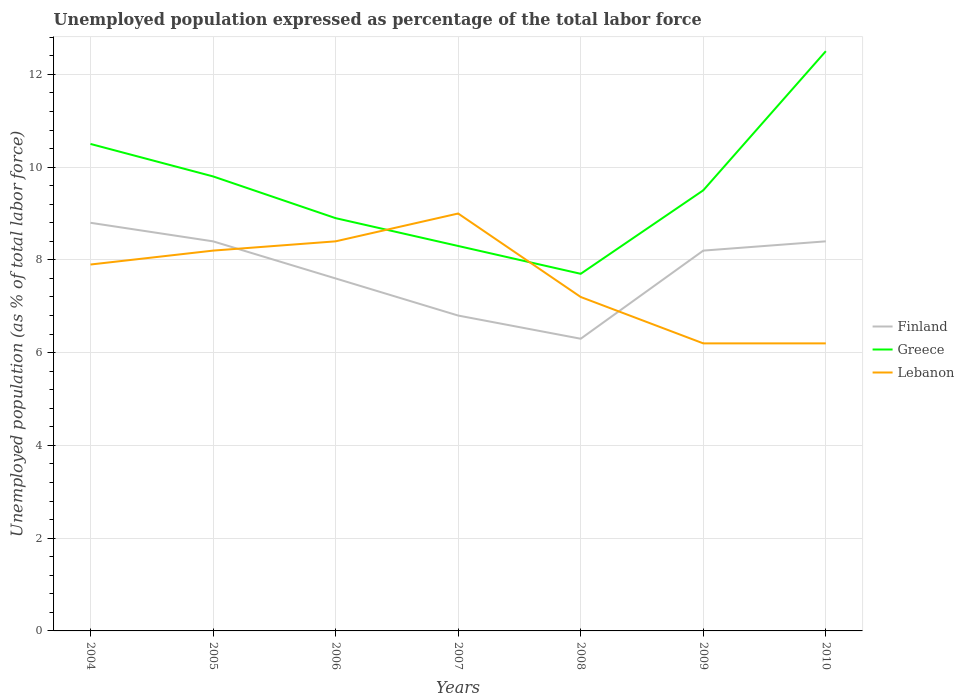How many different coloured lines are there?
Ensure brevity in your answer.  3. Does the line corresponding to Lebanon intersect with the line corresponding to Finland?
Offer a very short reply. Yes. Is the number of lines equal to the number of legend labels?
Make the answer very short. Yes. Across all years, what is the maximum unemployment in in Greece?
Offer a terse response. 7.7. What is the total unemployment in in Finland in the graph?
Your answer should be compact. 0.5. What is the difference between the highest and the second highest unemployment in in Greece?
Give a very brief answer. 4.8. How many years are there in the graph?
Your answer should be compact. 7. What is the difference between two consecutive major ticks on the Y-axis?
Offer a terse response. 2. Does the graph contain grids?
Keep it short and to the point. Yes. How many legend labels are there?
Provide a short and direct response. 3. How are the legend labels stacked?
Keep it short and to the point. Vertical. What is the title of the graph?
Give a very brief answer. Unemployed population expressed as percentage of the total labor force. Does "Moldova" appear as one of the legend labels in the graph?
Make the answer very short. No. What is the label or title of the Y-axis?
Offer a terse response. Unemployed population (as % of total labor force). What is the Unemployed population (as % of total labor force) in Finland in 2004?
Give a very brief answer. 8.8. What is the Unemployed population (as % of total labor force) of Lebanon in 2004?
Make the answer very short. 7.9. What is the Unemployed population (as % of total labor force) of Finland in 2005?
Your response must be concise. 8.4. What is the Unemployed population (as % of total labor force) of Greece in 2005?
Provide a short and direct response. 9.8. What is the Unemployed population (as % of total labor force) of Lebanon in 2005?
Keep it short and to the point. 8.2. What is the Unemployed population (as % of total labor force) in Finland in 2006?
Your answer should be very brief. 7.6. What is the Unemployed population (as % of total labor force) in Greece in 2006?
Offer a terse response. 8.9. What is the Unemployed population (as % of total labor force) in Lebanon in 2006?
Make the answer very short. 8.4. What is the Unemployed population (as % of total labor force) in Finland in 2007?
Your response must be concise. 6.8. What is the Unemployed population (as % of total labor force) in Greece in 2007?
Keep it short and to the point. 8.3. What is the Unemployed population (as % of total labor force) in Finland in 2008?
Make the answer very short. 6.3. What is the Unemployed population (as % of total labor force) of Greece in 2008?
Make the answer very short. 7.7. What is the Unemployed population (as % of total labor force) of Lebanon in 2008?
Provide a short and direct response. 7.2. What is the Unemployed population (as % of total labor force) of Finland in 2009?
Your answer should be compact. 8.2. What is the Unemployed population (as % of total labor force) in Lebanon in 2009?
Your answer should be compact. 6.2. What is the Unemployed population (as % of total labor force) of Finland in 2010?
Provide a short and direct response. 8.4. What is the Unemployed population (as % of total labor force) of Lebanon in 2010?
Your answer should be very brief. 6.2. Across all years, what is the maximum Unemployed population (as % of total labor force) in Finland?
Ensure brevity in your answer.  8.8. Across all years, what is the maximum Unemployed population (as % of total labor force) in Greece?
Provide a short and direct response. 12.5. Across all years, what is the maximum Unemployed population (as % of total labor force) of Lebanon?
Your response must be concise. 9. Across all years, what is the minimum Unemployed population (as % of total labor force) of Finland?
Keep it short and to the point. 6.3. Across all years, what is the minimum Unemployed population (as % of total labor force) in Greece?
Provide a succinct answer. 7.7. Across all years, what is the minimum Unemployed population (as % of total labor force) in Lebanon?
Provide a short and direct response. 6.2. What is the total Unemployed population (as % of total labor force) of Finland in the graph?
Your answer should be compact. 54.5. What is the total Unemployed population (as % of total labor force) in Greece in the graph?
Your answer should be compact. 67.2. What is the total Unemployed population (as % of total labor force) in Lebanon in the graph?
Your answer should be compact. 53.1. What is the difference between the Unemployed population (as % of total labor force) in Finland in 2004 and that in 2005?
Offer a very short reply. 0.4. What is the difference between the Unemployed population (as % of total labor force) in Lebanon in 2004 and that in 2007?
Make the answer very short. -1.1. What is the difference between the Unemployed population (as % of total labor force) in Lebanon in 2004 and that in 2008?
Give a very brief answer. 0.7. What is the difference between the Unemployed population (as % of total labor force) in Greece in 2004 and that in 2009?
Provide a short and direct response. 1. What is the difference between the Unemployed population (as % of total labor force) in Lebanon in 2004 and that in 2009?
Provide a short and direct response. 1.7. What is the difference between the Unemployed population (as % of total labor force) of Greece in 2004 and that in 2010?
Provide a succinct answer. -2. What is the difference between the Unemployed population (as % of total labor force) in Lebanon in 2004 and that in 2010?
Provide a short and direct response. 1.7. What is the difference between the Unemployed population (as % of total labor force) of Greece in 2005 and that in 2006?
Provide a short and direct response. 0.9. What is the difference between the Unemployed population (as % of total labor force) of Lebanon in 2005 and that in 2007?
Give a very brief answer. -0.8. What is the difference between the Unemployed population (as % of total labor force) in Lebanon in 2005 and that in 2008?
Make the answer very short. 1. What is the difference between the Unemployed population (as % of total labor force) in Finland in 2005 and that in 2010?
Offer a terse response. 0. What is the difference between the Unemployed population (as % of total labor force) in Greece in 2005 and that in 2010?
Your answer should be compact. -2.7. What is the difference between the Unemployed population (as % of total labor force) of Lebanon in 2006 and that in 2008?
Your answer should be compact. 1.2. What is the difference between the Unemployed population (as % of total labor force) of Finland in 2006 and that in 2009?
Offer a terse response. -0.6. What is the difference between the Unemployed population (as % of total labor force) of Finland in 2007 and that in 2008?
Your answer should be compact. 0.5. What is the difference between the Unemployed population (as % of total labor force) of Finland in 2007 and that in 2009?
Provide a succinct answer. -1.4. What is the difference between the Unemployed population (as % of total labor force) in Greece in 2007 and that in 2009?
Your answer should be very brief. -1.2. What is the difference between the Unemployed population (as % of total labor force) in Lebanon in 2007 and that in 2009?
Your response must be concise. 2.8. What is the difference between the Unemployed population (as % of total labor force) of Finland in 2008 and that in 2009?
Provide a succinct answer. -1.9. What is the difference between the Unemployed population (as % of total labor force) in Greece in 2008 and that in 2010?
Your response must be concise. -4.8. What is the difference between the Unemployed population (as % of total labor force) of Lebanon in 2008 and that in 2010?
Offer a terse response. 1. What is the difference between the Unemployed population (as % of total labor force) in Finland in 2009 and that in 2010?
Provide a short and direct response. -0.2. What is the difference between the Unemployed population (as % of total labor force) in Finland in 2004 and the Unemployed population (as % of total labor force) in Greece in 2005?
Your answer should be very brief. -1. What is the difference between the Unemployed population (as % of total labor force) of Greece in 2004 and the Unemployed population (as % of total labor force) of Lebanon in 2005?
Your answer should be compact. 2.3. What is the difference between the Unemployed population (as % of total labor force) of Finland in 2004 and the Unemployed population (as % of total labor force) of Lebanon in 2006?
Your response must be concise. 0.4. What is the difference between the Unemployed population (as % of total labor force) of Finland in 2004 and the Unemployed population (as % of total labor force) of Greece in 2007?
Your answer should be very brief. 0.5. What is the difference between the Unemployed population (as % of total labor force) of Finland in 2004 and the Unemployed population (as % of total labor force) of Lebanon in 2007?
Your answer should be very brief. -0.2. What is the difference between the Unemployed population (as % of total labor force) of Greece in 2004 and the Unemployed population (as % of total labor force) of Lebanon in 2007?
Make the answer very short. 1.5. What is the difference between the Unemployed population (as % of total labor force) in Finland in 2004 and the Unemployed population (as % of total labor force) in Greece in 2008?
Keep it short and to the point. 1.1. What is the difference between the Unemployed population (as % of total labor force) in Greece in 2004 and the Unemployed population (as % of total labor force) in Lebanon in 2008?
Ensure brevity in your answer.  3.3. What is the difference between the Unemployed population (as % of total labor force) in Finland in 2004 and the Unemployed population (as % of total labor force) in Greece in 2009?
Provide a short and direct response. -0.7. What is the difference between the Unemployed population (as % of total labor force) in Finland in 2004 and the Unemployed population (as % of total labor force) in Lebanon in 2009?
Make the answer very short. 2.6. What is the difference between the Unemployed population (as % of total labor force) of Greece in 2004 and the Unemployed population (as % of total labor force) of Lebanon in 2010?
Keep it short and to the point. 4.3. What is the difference between the Unemployed population (as % of total labor force) of Finland in 2005 and the Unemployed population (as % of total labor force) of Greece in 2006?
Your response must be concise. -0.5. What is the difference between the Unemployed population (as % of total labor force) of Greece in 2005 and the Unemployed population (as % of total labor force) of Lebanon in 2006?
Provide a short and direct response. 1.4. What is the difference between the Unemployed population (as % of total labor force) of Finland in 2005 and the Unemployed population (as % of total labor force) of Greece in 2007?
Your answer should be compact. 0.1. What is the difference between the Unemployed population (as % of total labor force) of Finland in 2005 and the Unemployed population (as % of total labor force) of Lebanon in 2007?
Your response must be concise. -0.6. What is the difference between the Unemployed population (as % of total labor force) of Finland in 2005 and the Unemployed population (as % of total labor force) of Lebanon in 2008?
Give a very brief answer. 1.2. What is the difference between the Unemployed population (as % of total labor force) in Finland in 2005 and the Unemployed population (as % of total labor force) in Lebanon in 2009?
Ensure brevity in your answer.  2.2. What is the difference between the Unemployed population (as % of total labor force) in Greece in 2005 and the Unemployed population (as % of total labor force) in Lebanon in 2009?
Your answer should be compact. 3.6. What is the difference between the Unemployed population (as % of total labor force) of Finland in 2005 and the Unemployed population (as % of total labor force) of Greece in 2010?
Provide a succinct answer. -4.1. What is the difference between the Unemployed population (as % of total labor force) in Greece in 2005 and the Unemployed population (as % of total labor force) in Lebanon in 2010?
Give a very brief answer. 3.6. What is the difference between the Unemployed population (as % of total labor force) of Finland in 2006 and the Unemployed population (as % of total labor force) of Lebanon in 2007?
Your answer should be very brief. -1.4. What is the difference between the Unemployed population (as % of total labor force) of Greece in 2006 and the Unemployed population (as % of total labor force) of Lebanon in 2007?
Provide a succinct answer. -0.1. What is the difference between the Unemployed population (as % of total labor force) of Finland in 2006 and the Unemployed population (as % of total labor force) of Lebanon in 2008?
Your answer should be very brief. 0.4. What is the difference between the Unemployed population (as % of total labor force) in Greece in 2006 and the Unemployed population (as % of total labor force) in Lebanon in 2008?
Make the answer very short. 1.7. What is the difference between the Unemployed population (as % of total labor force) of Finland in 2006 and the Unemployed population (as % of total labor force) of Greece in 2009?
Your response must be concise. -1.9. What is the difference between the Unemployed population (as % of total labor force) in Finland in 2006 and the Unemployed population (as % of total labor force) in Greece in 2010?
Provide a succinct answer. -4.9. What is the difference between the Unemployed population (as % of total labor force) in Finland in 2007 and the Unemployed population (as % of total labor force) in Lebanon in 2008?
Your answer should be compact. -0.4. What is the difference between the Unemployed population (as % of total labor force) of Greece in 2007 and the Unemployed population (as % of total labor force) of Lebanon in 2008?
Make the answer very short. 1.1. What is the difference between the Unemployed population (as % of total labor force) of Finland in 2007 and the Unemployed population (as % of total labor force) of Greece in 2009?
Make the answer very short. -2.7. What is the difference between the Unemployed population (as % of total labor force) of Finland in 2007 and the Unemployed population (as % of total labor force) of Lebanon in 2010?
Your answer should be very brief. 0.6. What is the difference between the Unemployed population (as % of total labor force) in Finland in 2008 and the Unemployed population (as % of total labor force) in Greece in 2009?
Ensure brevity in your answer.  -3.2. What is the difference between the Unemployed population (as % of total labor force) in Greece in 2008 and the Unemployed population (as % of total labor force) in Lebanon in 2009?
Your answer should be very brief. 1.5. What is the difference between the Unemployed population (as % of total labor force) of Finland in 2008 and the Unemployed population (as % of total labor force) of Lebanon in 2010?
Your response must be concise. 0.1. What is the difference between the Unemployed population (as % of total labor force) of Finland in 2009 and the Unemployed population (as % of total labor force) of Lebanon in 2010?
Your response must be concise. 2. What is the average Unemployed population (as % of total labor force) in Finland per year?
Provide a succinct answer. 7.79. What is the average Unemployed population (as % of total labor force) of Lebanon per year?
Your answer should be compact. 7.59. In the year 2004, what is the difference between the Unemployed population (as % of total labor force) in Finland and Unemployed population (as % of total labor force) in Greece?
Provide a short and direct response. -1.7. In the year 2004, what is the difference between the Unemployed population (as % of total labor force) in Finland and Unemployed population (as % of total labor force) in Lebanon?
Give a very brief answer. 0.9. In the year 2005, what is the difference between the Unemployed population (as % of total labor force) in Finland and Unemployed population (as % of total labor force) in Greece?
Offer a terse response. -1.4. In the year 2005, what is the difference between the Unemployed population (as % of total labor force) in Finland and Unemployed population (as % of total labor force) in Lebanon?
Keep it short and to the point. 0.2. In the year 2005, what is the difference between the Unemployed population (as % of total labor force) in Greece and Unemployed population (as % of total labor force) in Lebanon?
Provide a short and direct response. 1.6. In the year 2007, what is the difference between the Unemployed population (as % of total labor force) in Finland and Unemployed population (as % of total labor force) in Greece?
Offer a terse response. -1.5. In the year 2007, what is the difference between the Unemployed population (as % of total labor force) in Greece and Unemployed population (as % of total labor force) in Lebanon?
Provide a succinct answer. -0.7. In the year 2008, what is the difference between the Unemployed population (as % of total labor force) of Finland and Unemployed population (as % of total labor force) of Greece?
Your response must be concise. -1.4. In the year 2008, what is the difference between the Unemployed population (as % of total labor force) of Greece and Unemployed population (as % of total labor force) of Lebanon?
Offer a very short reply. 0.5. In the year 2009, what is the difference between the Unemployed population (as % of total labor force) of Finland and Unemployed population (as % of total labor force) of Greece?
Your answer should be compact. -1.3. In the year 2010, what is the difference between the Unemployed population (as % of total labor force) of Finland and Unemployed population (as % of total labor force) of Lebanon?
Ensure brevity in your answer.  2.2. What is the ratio of the Unemployed population (as % of total labor force) in Finland in 2004 to that in 2005?
Make the answer very short. 1.05. What is the ratio of the Unemployed population (as % of total labor force) of Greece in 2004 to that in 2005?
Your answer should be compact. 1.07. What is the ratio of the Unemployed population (as % of total labor force) in Lebanon in 2004 to that in 2005?
Give a very brief answer. 0.96. What is the ratio of the Unemployed population (as % of total labor force) of Finland in 2004 to that in 2006?
Your answer should be compact. 1.16. What is the ratio of the Unemployed population (as % of total labor force) in Greece in 2004 to that in 2006?
Your answer should be very brief. 1.18. What is the ratio of the Unemployed population (as % of total labor force) in Lebanon in 2004 to that in 2006?
Offer a terse response. 0.94. What is the ratio of the Unemployed population (as % of total labor force) in Finland in 2004 to that in 2007?
Your response must be concise. 1.29. What is the ratio of the Unemployed population (as % of total labor force) of Greece in 2004 to that in 2007?
Give a very brief answer. 1.27. What is the ratio of the Unemployed population (as % of total labor force) in Lebanon in 2004 to that in 2007?
Ensure brevity in your answer.  0.88. What is the ratio of the Unemployed population (as % of total labor force) in Finland in 2004 to that in 2008?
Make the answer very short. 1.4. What is the ratio of the Unemployed population (as % of total labor force) in Greece in 2004 to that in 2008?
Provide a succinct answer. 1.36. What is the ratio of the Unemployed population (as % of total labor force) of Lebanon in 2004 to that in 2008?
Keep it short and to the point. 1.1. What is the ratio of the Unemployed population (as % of total labor force) of Finland in 2004 to that in 2009?
Provide a short and direct response. 1.07. What is the ratio of the Unemployed population (as % of total labor force) in Greece in 2004 to that in 2009?
Give a very brief answer. 1.11. What is the ratio of the Unemployed population (as % of total labor force) of Lebanon in 2004 to that in 2009?
Ensure brevity in your answer.  1.27. What is the ratio of the Unemployed population (as % of total labor force) of Finland in 2004 to that in 2010?
Ensure brevity in your answer.  1.05. What is the ratio of the Unemployed population (as % of total labor force) of Greece in 2004 to that in 2010?
Provide a succinct answer. 0.84. What is the ratio of the Unemployed population (as % of total labor force) of Lebanon in 2004 to that in 2010?
Provide a succinct answer. 1.27. What is the ratio of the Unemployed population (as % of total labor force) in Finland in 2005 to that in 2006?
Keep it short and to the point. 1.11. What is the ratio of the Unemployed population (as % of total labor force) of Greece in 2005 to that in 2006?
Your answer should be compact. 1.1. What is the ratio of the Unemployed population (as % of total labor force) in Lebanon in 2005 to that in 2006?
Offer a terse response. 0.98. What is the ratio of the Unemployed population (as % of total labor force) in Finland in 2005 to that in 2007?
Offer a very short reply. 1.24. What is the ratio of the Unemployed population (as % of total labor force) in Greece in 2005 to that in 2007?
Provide a short and direct response. 1.18. What is the ratio of the Unemployed population (as % of total labor force) in Lebanon in 2005 to that in 2007?
Provide a succinct answer. 0.91. What is the ratio of the Unemployed population (as % of total labor force) in Finland in 2005 to that in 2008?
Offer a very short reply. 1.33. What is the ratio of the Unemployed population (as % of total labor force) of Greece in 2005 to that in 2008?
Your response must be concise. 1.27. What is the ratio of the Unemployed population (as % of total labor force) of Lebanon in 2005 to that in 2008?
Your answer should be compact. 1.14. What is the ratio of the Unemployed population (as % of total labor force) of Finland in 2005 to that in 2009?
Your answer should be very brief. 1.02. What is the ratio of the Unemployed population (as % of total labor force) in Greece in 2005 to that in 2009?
Make the answer very short. 1.03. What is the ratio of the Unemployed population (as % of total labor force) in Lebanon in 2005 to that in 2009?
Your response must be concise. 1.32. What is the ratio of the Unemployed population (as % of total labor force) in Finland in 2005 to that in 2010?
Keep it short and to the point. 1. What is the ratio of the Unemployed population (as % of total labor force) in Greece in 2005 to that in 2010?
Provide a succinct answer. 0.78. What is the ratio of the Unemployed population (as % of total labor force) of Lebanon in 2005 to that in 2010?
Provide a short and direct response. 1.32. What is the ratio of the Unemployed population (as % of total labor force) in Finland in 2006 to that in 2007?
Make the answer very short. 1.12. What is the ratio of the Unemployed population (as % of total labor force) in Greece in 2006 to that in 2007?
Ensure brevity in your answer.  1.07. What is the ratio of the Unemployed population (as % of total labor force) of Finland in 2006 to that in 2008?
Ensure brevity in your answer.  1.21. What is the ratio of the Unemployed population (as % of total labor force) in Greece in 2006 to that in 2008?
Offer a terse response. 1.16. What is the ratio of the Unemployed population (as % of total labor force) in Lebanon in 2006 to that in 2008?
Give a very brief answer. 1.17. What is the ratio of the Unemployed population (as % of total labor force) in Finland in 2006 to that in 2009?
Your answer should be compact. 0.93. What is the ratio of the Unemployed population (as % of total labor force) in Greece in 2006 to that in 2009?
Your answer should be very brief. 0.94. What is the ratio of the Unemployed population (as % of total labor force) of Lebanon in 2006 to that in 2009?
Make the answer very short. 1.35. What is the ratio of the Unemployed population (as % of total labor force) in Finland in 2006 to that in 2010?
Provide a short and direct response. 0.9. What is the ratio of the Unemployed population (as % of total labor force) of Greece in 2006 to that in 2010?
Your response must be concise. 0.71. What is the ratio of the Unemployed population (as % of total labor force) of Lebanon in 2006 to that in 2010?
Offer a very short reply. 1.35. What is the ratio of the Unemployed population (as % of total labor force) of Finland in 2007 to that in 2008?
Provide a short and direct response. 1.08. What is the ratio of the Unemployed population (as % of total labor force) in Greece in 2007 to that in 2008?
Provide a succinct answer. 1.08. What is the ratio of the Unemployed population (as % of total labor force) in Lebanon in 2007 to that in 2008?
Offer a terse response. 1.25. What is the ratio of the Unemployed population (as % of total labor force) of Finland in 2007 to that in 2009?
Provide a short and direct response. 0.83. What is the ratio of the Unemployed population (as % of total labor force) in Greece in 2007 to that in 2009?
Give a very brief answer. 0.87. What is the ratio of the Unemployed population (as % of total labor force) of Lebanon in 2007 to that in 2009?
Your answer should be very brief. 1.45. What is the ratio of the Unemployed population (as % of total labor force) in Finland in 2007 to that in 2010?
Give a very brief answer. 0.81. What is the ratio of the Unemployed population (as % of total labor force) of Greece in 2007 to that in 2010?
Provide a short and direct response. 0.66. What is the ratio of the Unemployed population (as % of total labor force) of Lebanon in 2007 to that in 2010?
Provide a short and direct response. 1.45. What is the ratio of the Unemployed population (as % of total labor force) of Finland in 2008 to that in 2009?
Your response must be concise. 0.77. What is the ratio of the Unemployed population (as % of total labor force) of Greece in 2008 to that in 2009?
Keep it short and to the point. 0.81. What is the ratio of the Unemployed population (as % of total labor force) of Lebanon in 2008 to that in 2009?
Offer a terse response. 1.16. What is the ratio of the Unemployed population (as % of total labor force) of Finland in 2008 to that in 2010?
Your answer should be compact. 0.75. What is the ratio of the Unemployed population (as % of total labor force) of Greece in 2008 to that in 2010?
Offer a very short reply. 0.62. What is the ratio of the Unemployed population (as % of total labor force) in Lebanon in 2008 to that in 2010?
Offer a very short reply. 1.16. What is the ratio of the Unemployed population (as % of total labor force) of Finland in 2009 to that in 2010?
Give a very brief answer. 0.98. What is the ratio of the Unemployed population (as % of total labor force) in Greece in 2009 to that in 2010?
Ensure brevity in your answer.  0.76. What is the difference between the highest and the lowest Unemployed population (as % of total labor force) in Finland?
Offer a very short reply. 2.5. What is the difference between the highest and the lowest Unemployed population (as % of total labor force) in Greece?
Your response must be concise. 4.8. What is the difference between the highest and the lowest Unemployed population (as % of total labor force) of Lebanon?
Give a very brief answer. 2.8. 